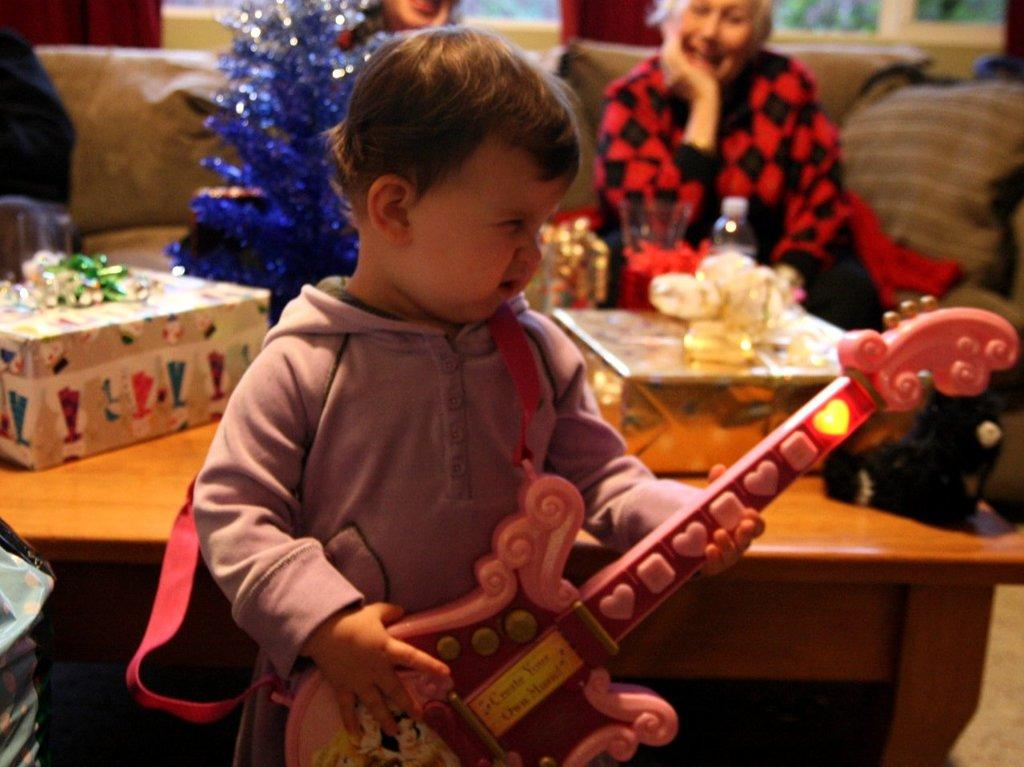Who is the main subject in the image? There is a boy in the image. What is the boy holding in the image? The boy is holding a guitar. What can be seen on a table in the background of the image? There are gifts on a table in the background. What are the two persons in the background doing? There are two persons sitting on chairs in the background. What door does the boy walk through in the image? There is no door present in the image, nor is the boy walking through any door. 